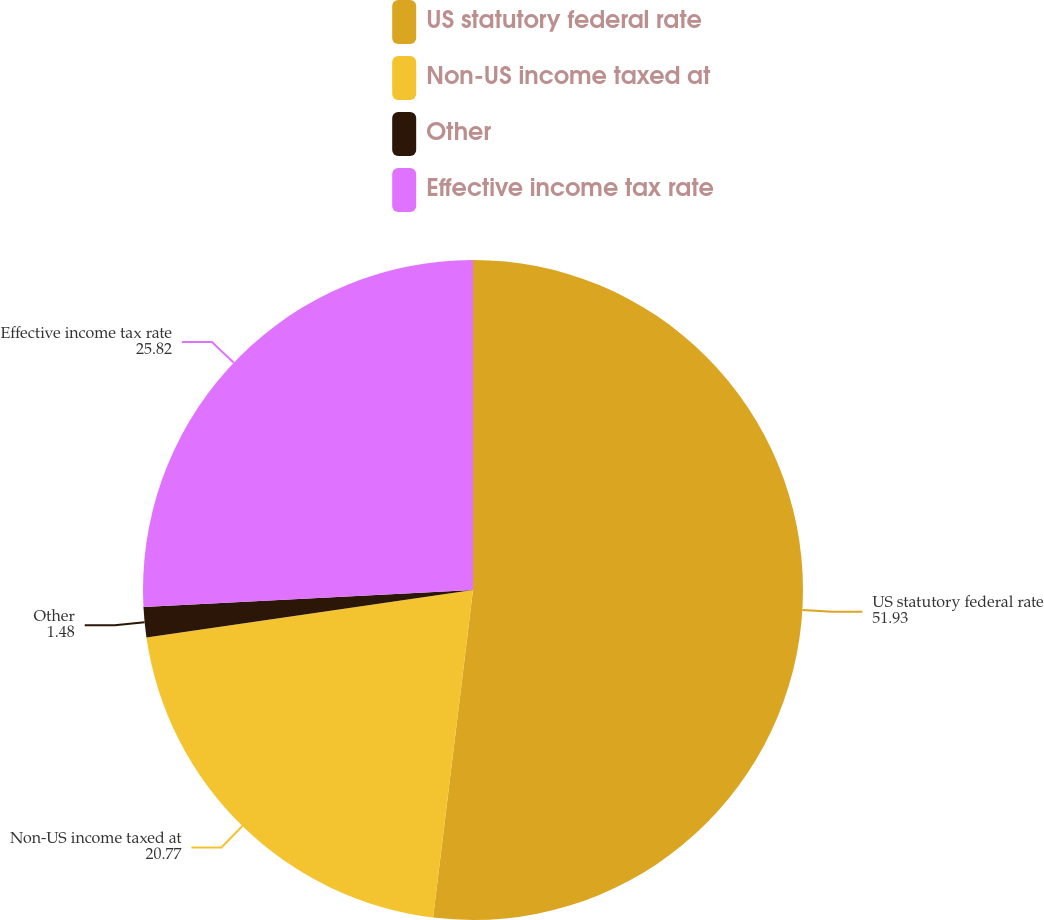<chart> <loc_0><loc_0><loc_500><loc_500><pie_chart><fcel>US statutory federal rate<fcel>Non-US income taxed at<fcel>Other<fcel>Effective income tax rate<nl><fcel>51.93%<fcel>20.77%<fcel>1.48%<fcel>25.82%<nl></chart> 